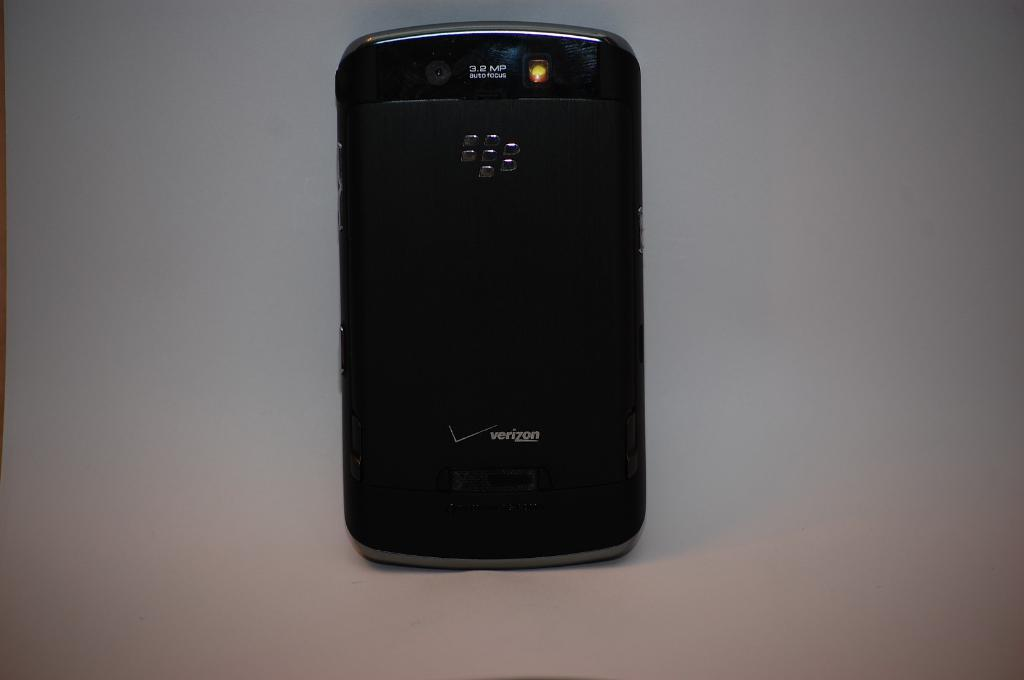Provide a one-sentence caption for the provided image. The back of a black cell phone displays the Verizon name and logo. 